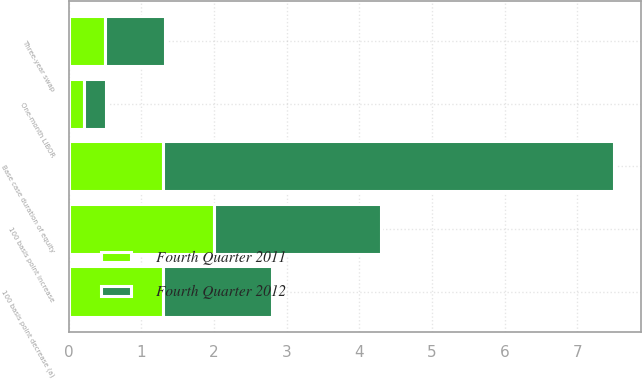Convert chart to OTSL. <chart><loc_0><loc_0><loc_500><loc_500><stacked_bar_chart><ecel><fcel>100 basis point increase<fcel>100 basis point decrease (a)<fcel>Base case duration of equity<fcel>One-month LIBOR<fcel>Three-year swap<nl><fcel>Fourth Quarter 2011<fcel>2<fcel>1.3<fcel>1.3<fcel>0.21<fcel>0.5<nl><fcel>Fourth Quarter 2012<fcel>2.3<fcel>1.5<fcel>6.2<fcel>0.3<fcel>0.82<nl></chart> 